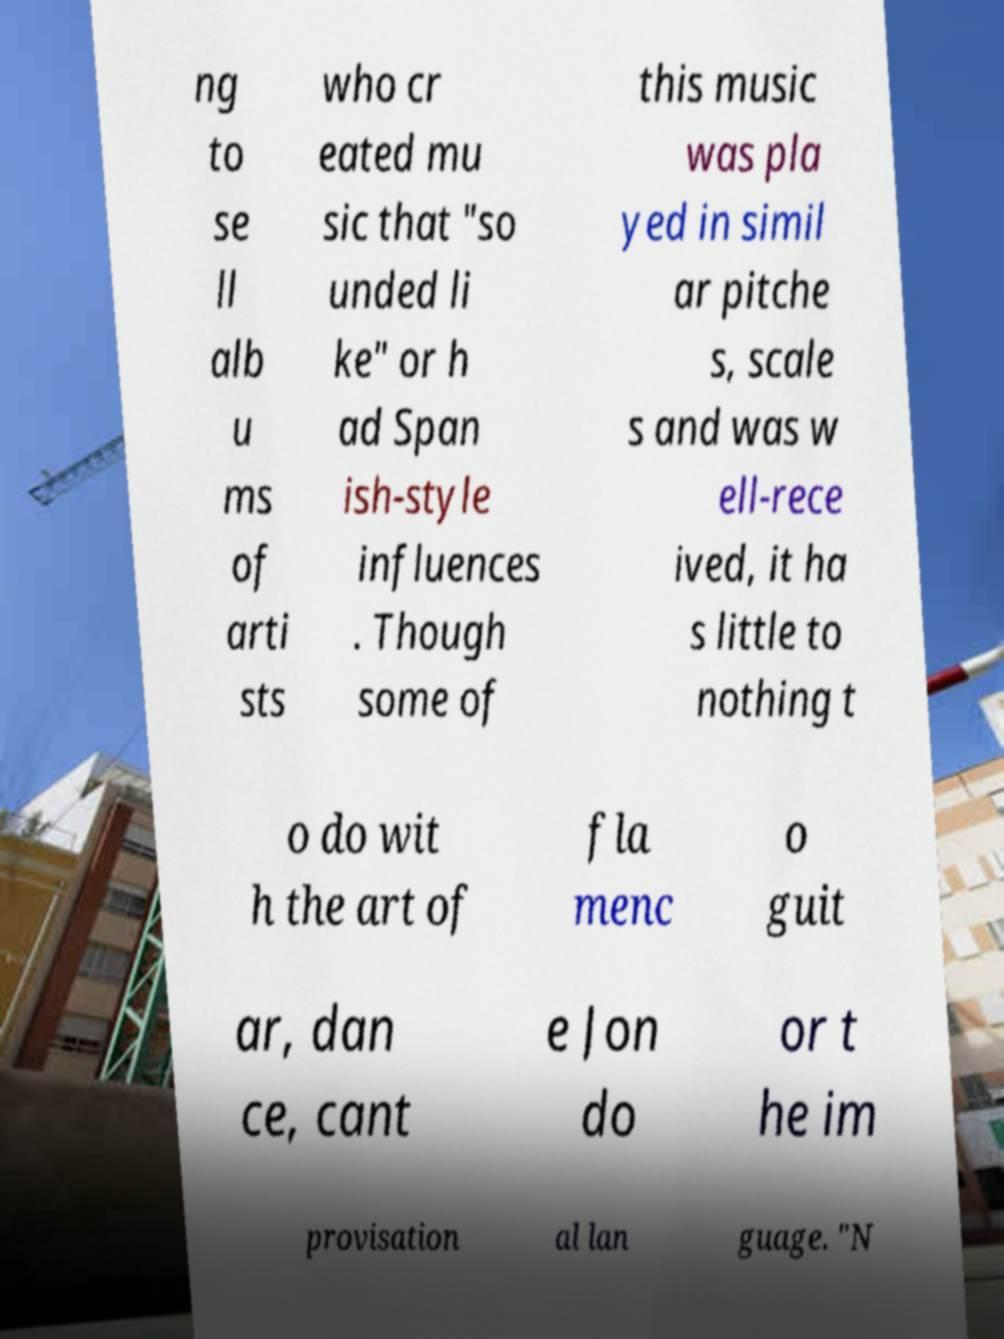I need the written content from this picture converted into text. Can you do that? ng to se ll alb u ms of arti sts who cr eated mu sic that "so unded li ke" or h ad Span ish-style influences . Though some of this music was pla yed in simil ar pitche s, scale s and was w ell-rece ived, it ha s little to nothing t o do wit h the art of fla menc o guit ar, dan ce, cant e Jon do or t he im provisation al lan guage. "N 